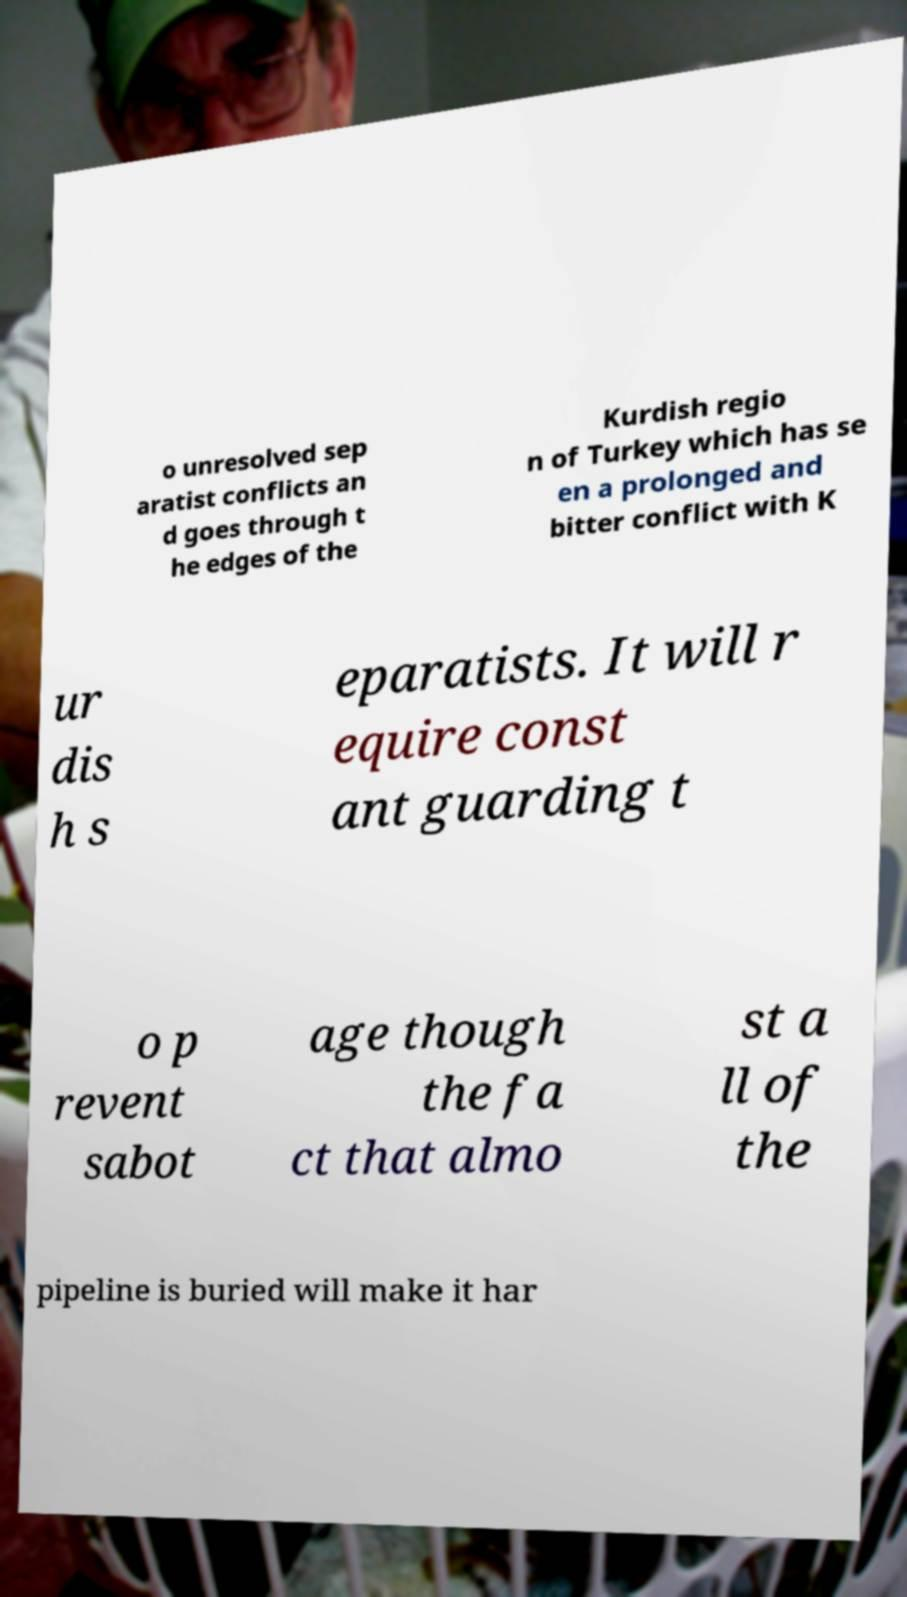Please read and relay the text visible in this image. What does it say? o unresolved sep aratist conflicts an d goes through t he edges of the Kurdish regio n of Turkey which has se en a prolonged and bitter conflict with K ur dis h s eparatists. It will r equire const ant guarding t o p revent sabot age though the fa ct that almo st a ll of the pipeline is buried will make it har 